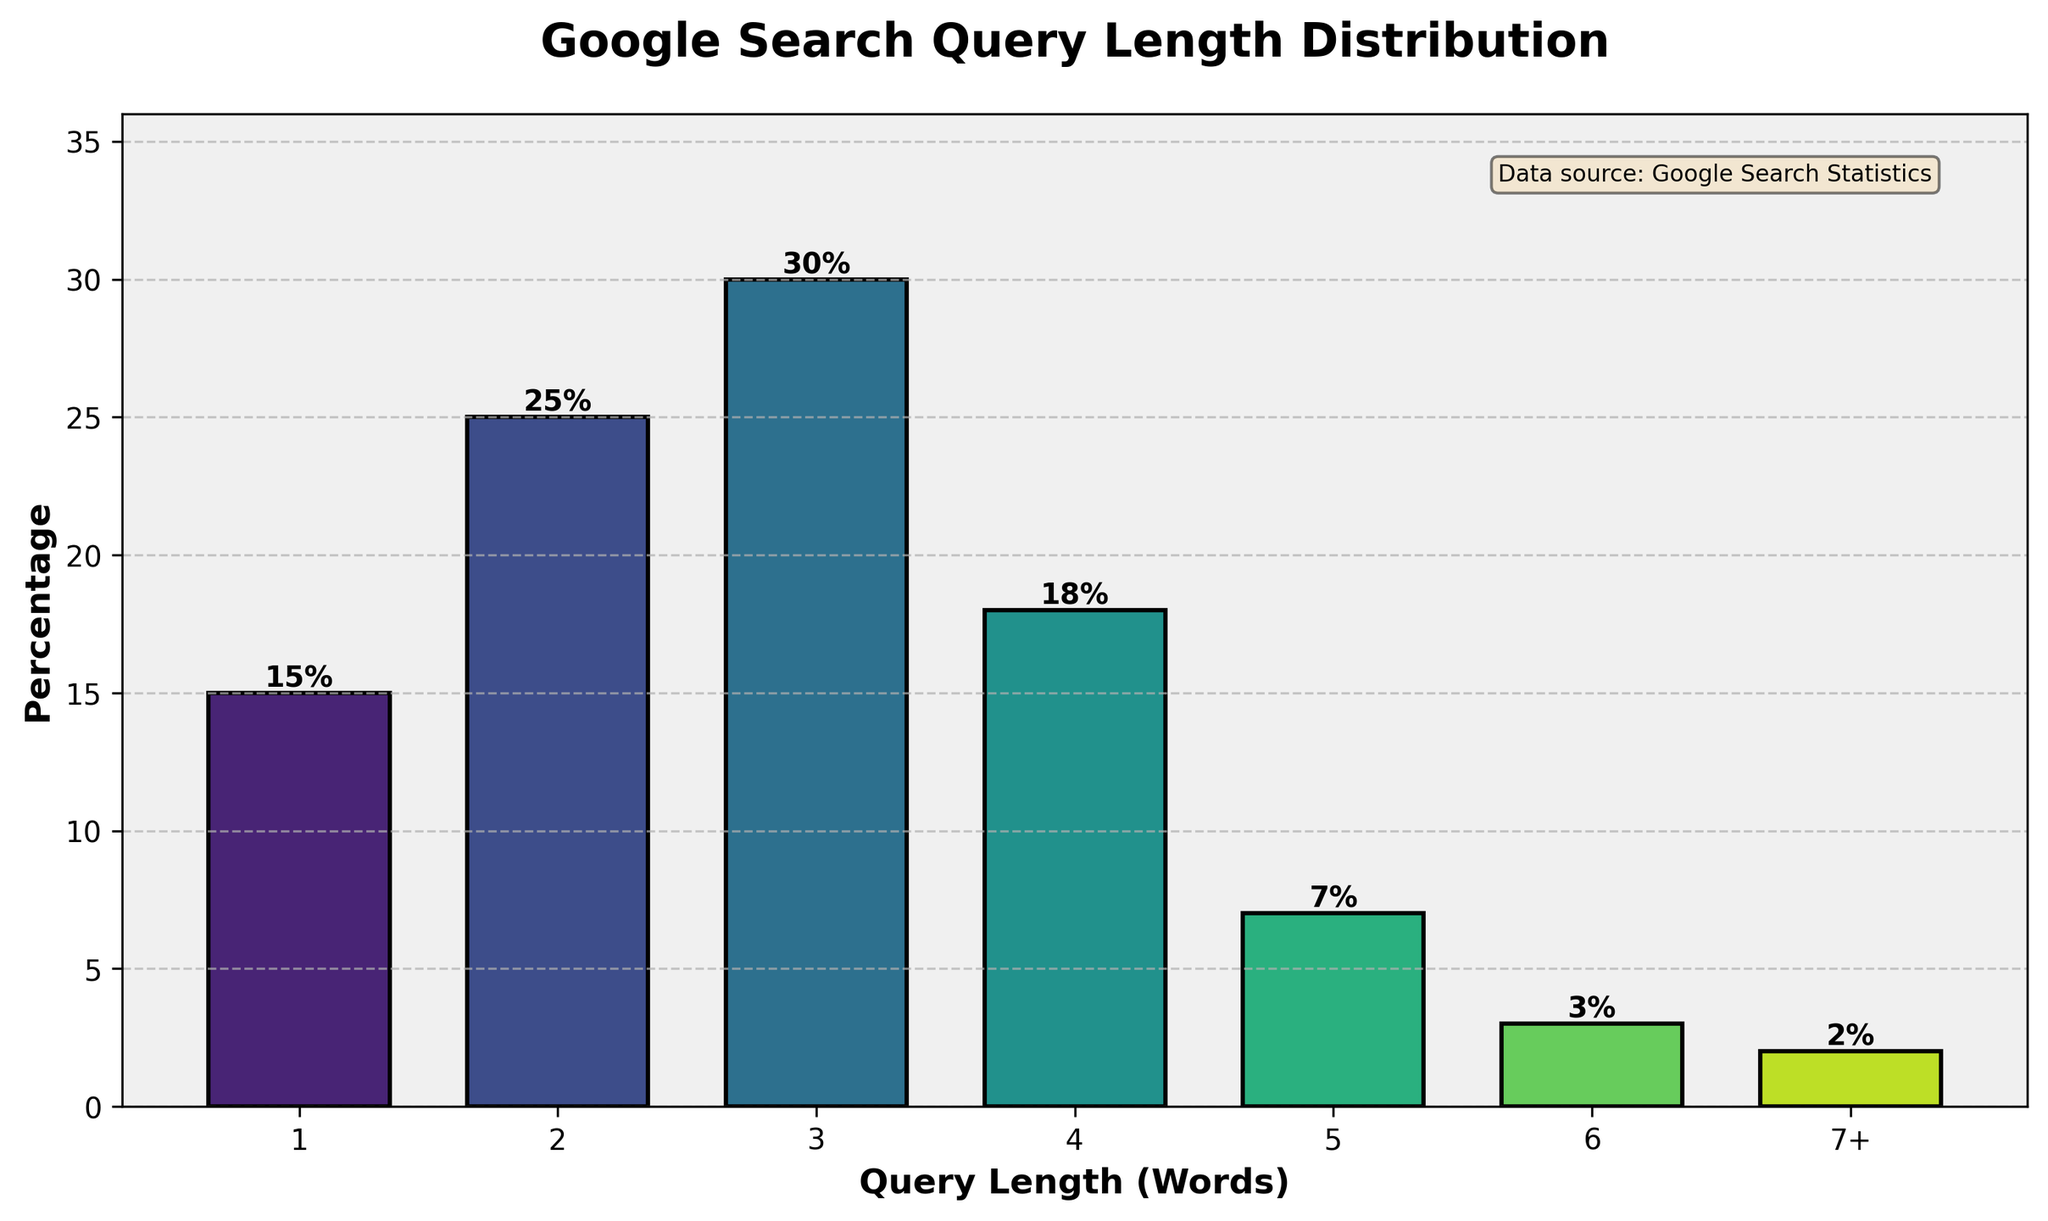What's the title of the figure? The title is typically placed at the top of the figure and describes the main topic of the histogram. By looking at the top of the plot, we can see this information.
Answer: Google Search Query Length Distribution How many distinct query length categories are represented in the histogram? By counting the number of bars in the histogram, we can determine the number of distinct query length categories. In this plot, there are 7 bars, each representing a different category.
Answer: 7 Which query length category has the highest percentage? To answer this, we look at the bar that reaches the highest point along the percentage axis. The tallest bar visually represents the highest percentage.
Answer: 3 words What is the combined percentage of search queries that are either 1 or 2 words long? Combine the percentages for the categories labeled 1 and 2 by adding them together: 15% (for 1-word queries) + 25% (for 2-word queries) = 40%.
Answer: 40% Does the percentage of search queries consistently decrease as the query length increases? Observing the heights of the bars, we see that the pattern is not strictly decreasing; it increases from 1 to 3 words, decreases from 3 to 6 words, and has a slight increase at "7+" words.
Answer: No What's the difference in percentage between the most and least common query lengths? Find the highest percentage (3 words at 30%) and the lowest percentage (7+ words at 2%), and subtract the smallest from the largest: 30% - 2% = 28%.
Answer: 28% What percentage of search queries are 5 words or longer? Add the percentages of all bars representing 5 words or more: 5 words (7%) + 6 words (3%) + 7+ words (2%) = 12%.
Answer: 12% Which query length categories have a percentage lower than 10%? By inspecting each bar, identify those that do not reach the 10% mark. The bars for 5 words (7%), 6 words (3%), and 7+ words (2%) meet this criterion.
Answer: 5 words, 6 words, 7+ words How many percentage points do 3-word queries exceed 4-word queries by? Compare the heights of the bars for 3-word queries (30%) and 4-word queries (18%) and subtract the smaller from the larger: 30% - 18% = 12%.
Answer: 12% 